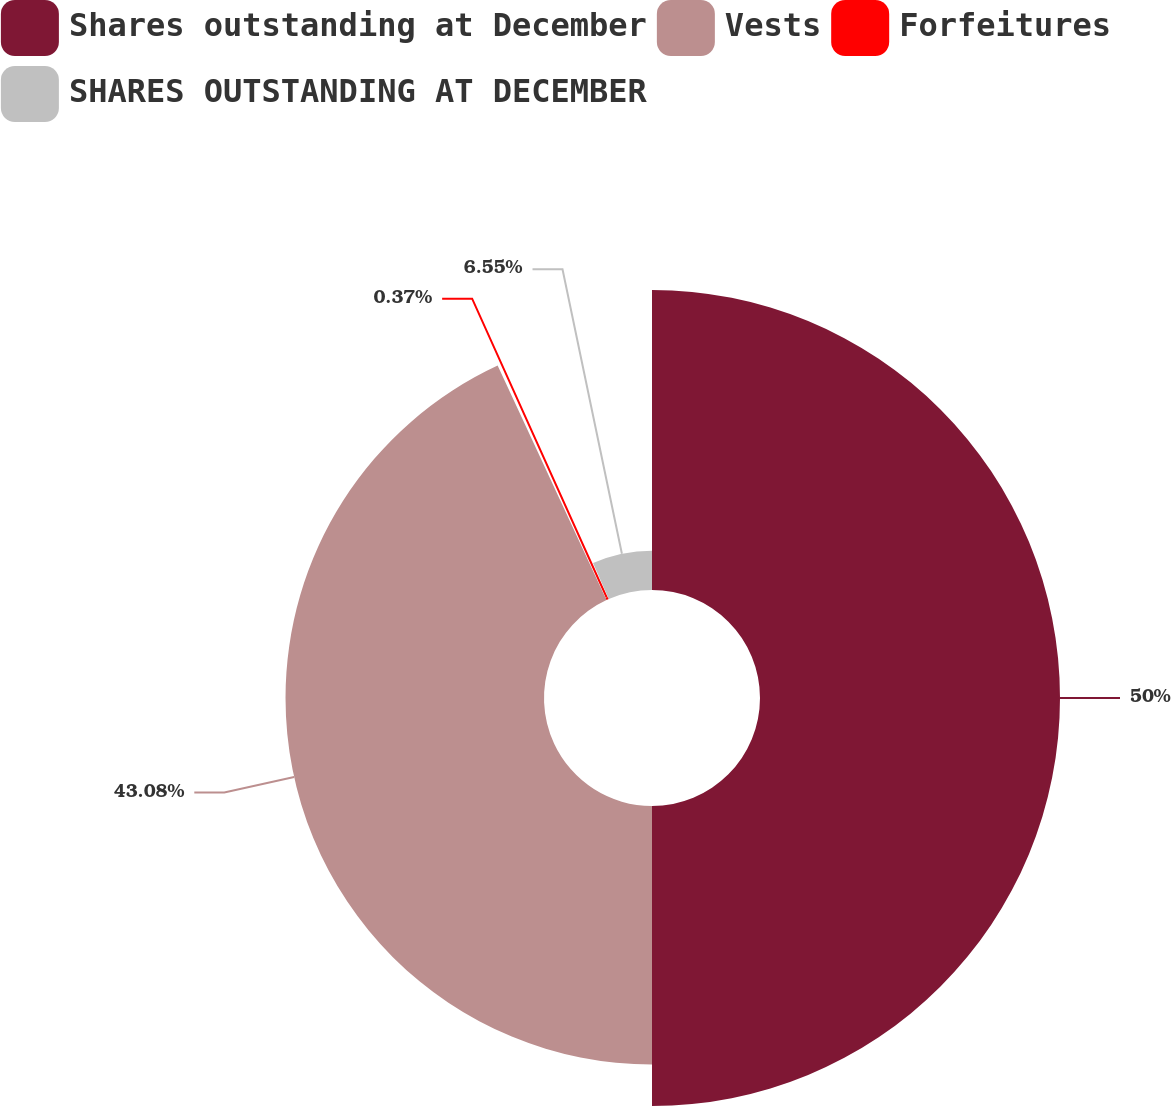<chart> <loc_0><loc_0><loc_500><loc_500><pie_chart><fcel>Shares outstanding at December<fcel>Vests<fcel>Forfeitures<fcel>SHARES OUTSTANDING AT DECEMBER<nl><fcel>50.0%<fcel>43.08%<fcel>0.37%<fcel>6.55%<nl></chart> 